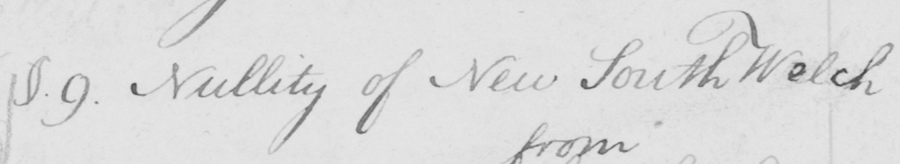Can you tell me what this handwritten text says? §.9 . Nullity of New South Welch 